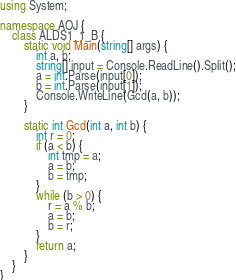Convert code to text. <code><loc_0><loc_0><loc_500><loc_500><_C#_>using System;

namespace AOJ {
    class ALDS1_1_B {
        static void Main(string[] args) {
            int a, b;
            string[] input = Console.ReadLine().Split();
            a = int.Parse(input[0]);
            b = int.Parse(input[1]);
            Console.WriteLine(Gcd(a, b));
        }

        static int Gcd(int a, int b) {
            int r = 0;
            if (a < b) {
                int tmp = a;
                a = b;
                b = tmp;
            }
            while (b > 0) {
                r = a % b;
                a = b;
                b = r;
            }
            return a;
        }
    }
}

</code> 